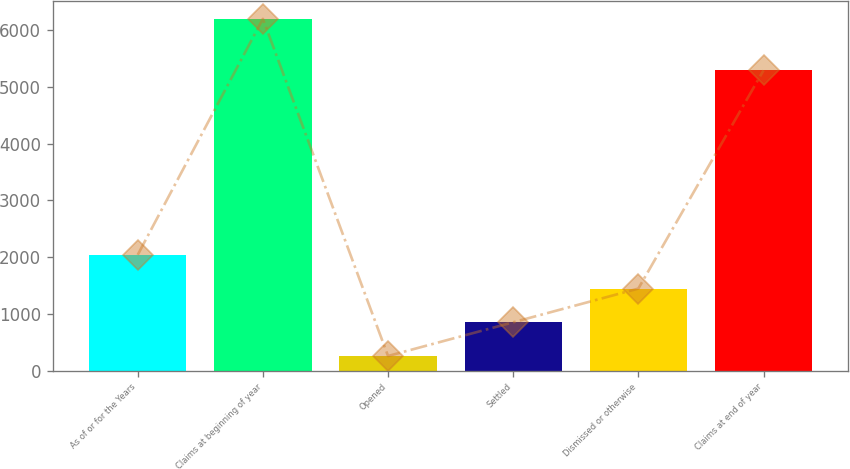<chart> <loc_0><loc_0><loc_500><loc_500><bar_chart><fcel>As of or for the Years<fcel>Claims at beginning of year<fcel>Opened<fcel>Settled<fcel>Dismissed or otherwise<fcel>Claims at end of year<nl><fcel>2038.3<fcel>6197<fcel>256<fcel>850.1<fcel>1444.2<fcel>5289<nl></chart> 